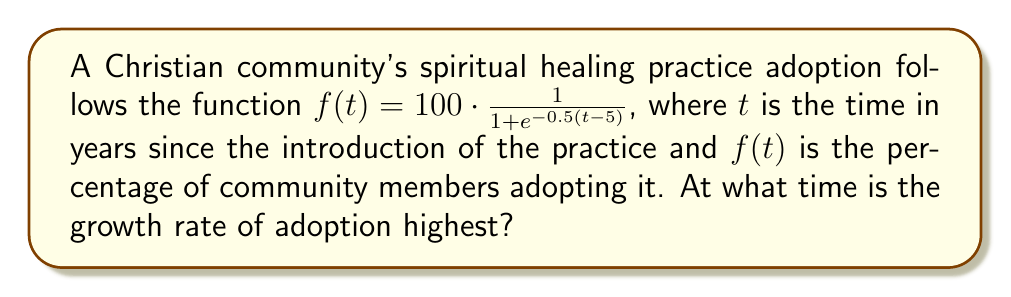Teach me how to tackle this problem. To find the time when the growth rate is highest, we need to find the maximum of the derivative of $f(t)$.

Step 1: Calculate the derivative of $f(t)$
Using the chain rule:
$$f'(t) = 100 \cdot \frac{e^{-0.5(t-5)}}{(1 + e^{-0.5(t-5)})^2} \cdot 0.5$$
$$f'(t) = 50 \cdot \frac{e^{-0.5(t-5)}}{(1 + e^{-0.5(t-5)})^2}$$

Step 2: Find the critical point by setting $f''(t) = 0$
The second derivative is complex, but we can observe that $f(t)$ is a logistic function, which is symmetric around its inflection point. For logistic functions, the inflection point occurs at the midpoint of the sigmoid curve, where $t-5 = 0$.

Step 3: Solve for t
$t - 5 = 0$
$t = 5$

Step 4: Verify this is a maximum
We can confirm this is a maximum by observing that the growth rate increases before $t=5$ and decreases after $t=5$.
Answer: 5 years 